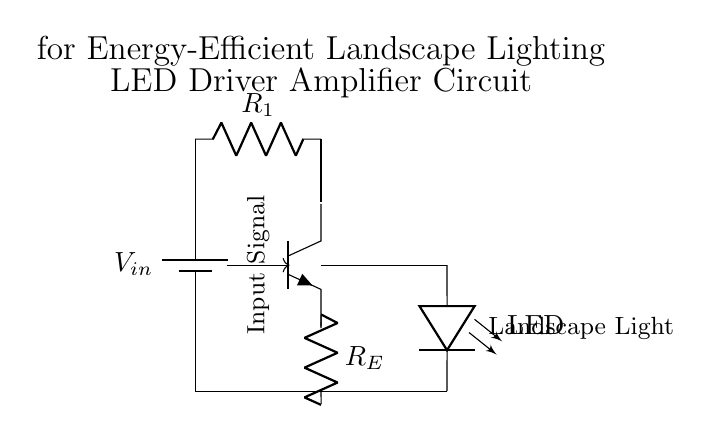What is the input signal type for this circuit? The circuit does not specify a particular type for the input signal, but it is commonly assumed to be a varying voltage signal used to control the amplifier.
Answer: varying voltage signal What component restricts the current flowing through the circuit? The resistor labeled R1 is used to limit the current, ensuring that the transistor operates within safe regions and protecting other components from excessive current.
Answer: R1 How many resistors are present in the circuit? There are two resistors in the circuit that are represented by R1 and RE, as clearly indicated in the schematic.
Answer: two What is the purpose of the transistor in this circuit? The transistor functions as an amplifier, increasing the signal strength to drive the LED and provide sufficient light output.
Answer: amplifier What type of load is being controlled by this circuit? The load controlled by the circuit is a light-emitting diode, commonly referred to as an LED, which provides illumination in the landscape lighting setup.
Answer: LED Which component acts as the main output driver for the light in this circuit? The LED is specifically designed as the output driver; it converts electrical energy into light and represents the primary component delivering illumination in the circuit.
Answer: LED 